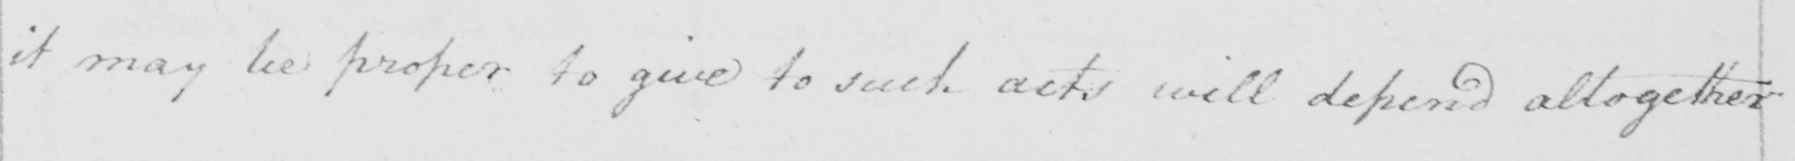What does this handwritten line say? it may be proper to give to such acts will depend altogether 